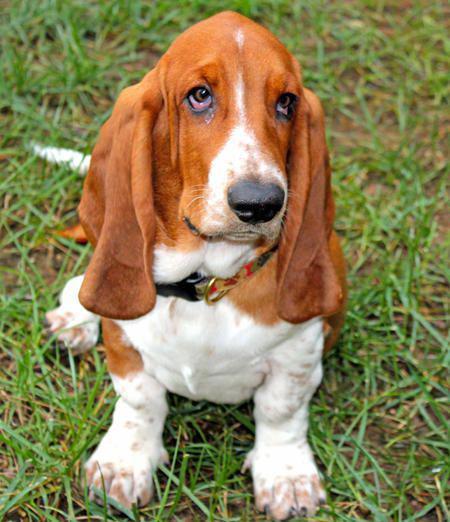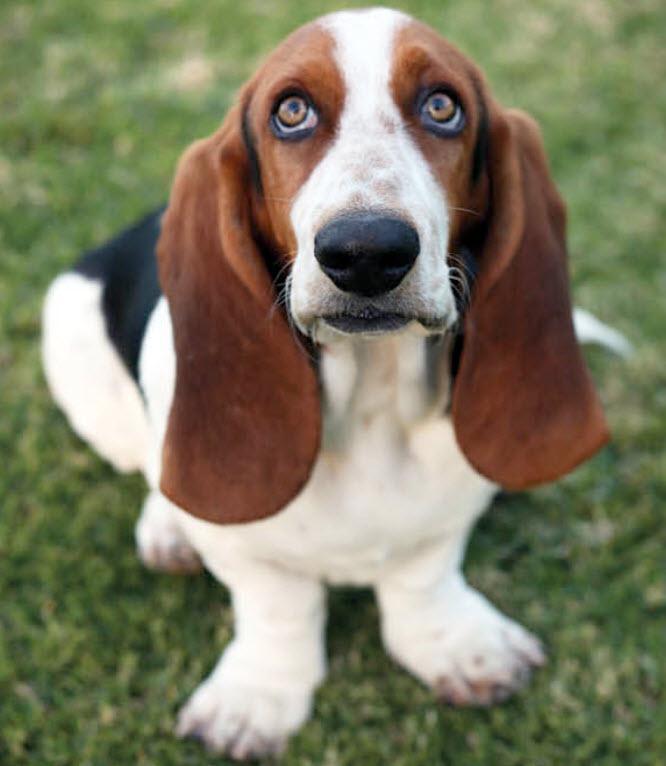The first image is the image on the left, the second image is the image on the right. Examine the images to the left and right. Is the description "One of the dog's front paws are not on the grass." accurate? Answer yes or no. No. The first image is the image on the left, the second image is the image on the right. Examine the images to the left and right. Is the description "All dogs pictured have visible collars." accurate? Answer yes or no. No. 